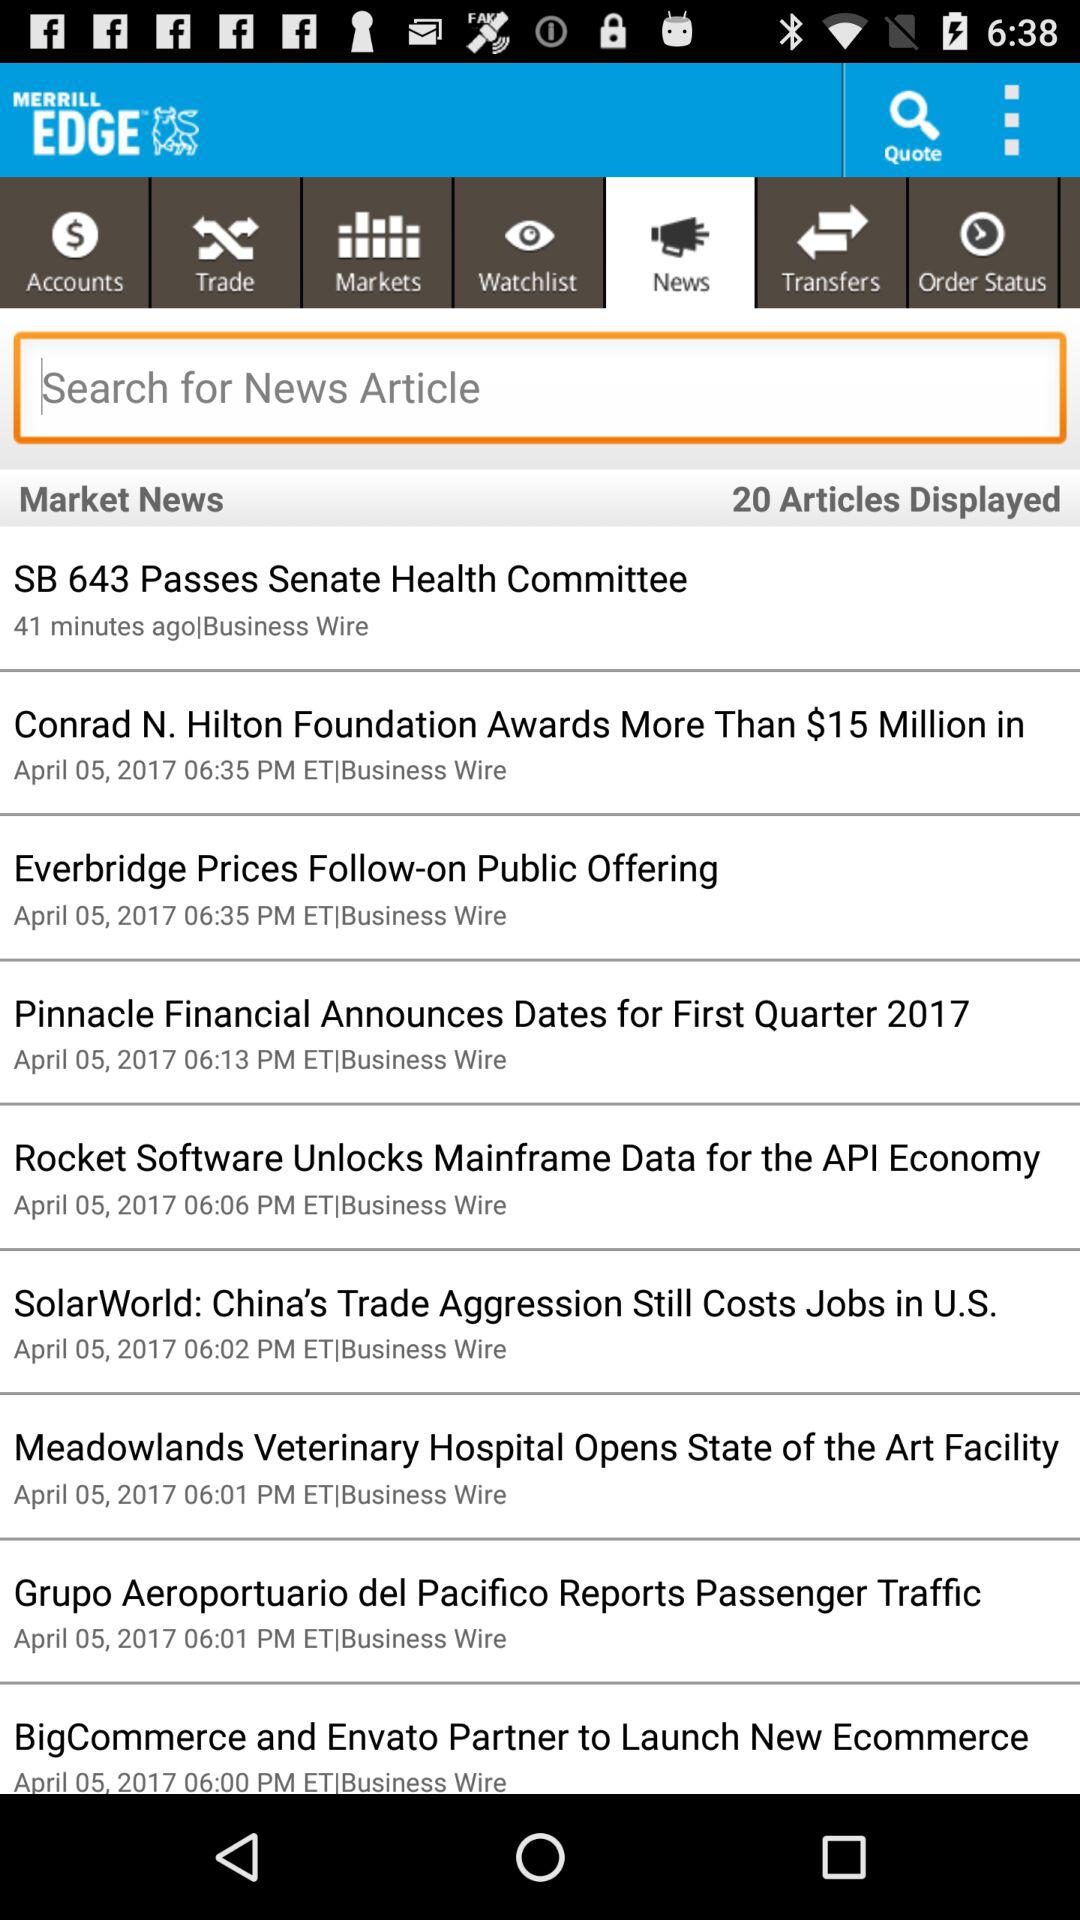How many articles are displayed?
Answer the question using a single word or phrase. 20 